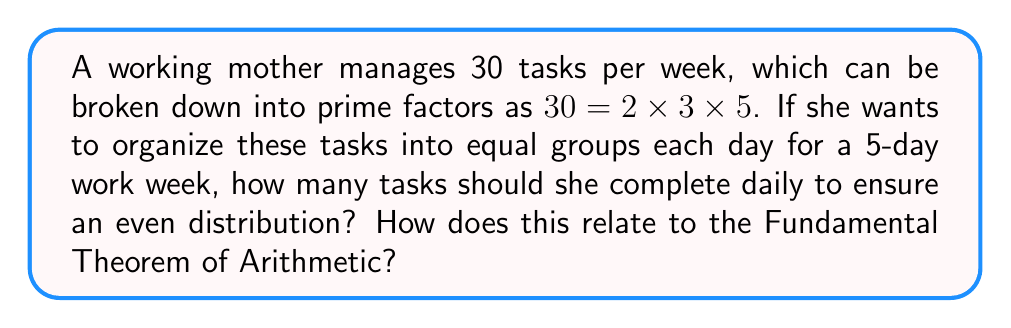Can you answer this question? Let's approach this step-by-step:

1) The Fundamental Theorem of Arithmetic states that every positive integer can be represented uniquely as a product of prime powers. In this case:

   $30 = 2 \times 3 \times 5$

2) To distribute the tasks evenly over 5 days, we need to find a factor of 30 that is also a multiple of 5. This ensures that the tasks can be divided equally among the 5 days.

3) Looking at the prime factorization, we can see that 5 is already a factor of 30.

4) Therefore, the number of tasks per day would be:

   $\frac{30}{5} = 2 \times 3 = 6$

5) This organization method relates to the Fundamental Theorem of Arithmetic because:
   
   a) It allows us to easily identify the factors of 30.
   b) We can quickly determine which prime factors (in this case, 5) align with our organizational needs (5-day work week).
   c) By using the prime factorization, we can efficiently reorganize tasks without needing to perform repeated divisions or trial-and-error.

6) This approach demonstrates how understanding the prime structure of numbers (as guaranteed by the Fundamental Theorem of Arithmetic) can lead to more efficient task organization and time management strategies.
Answer: 6 tasks per day 